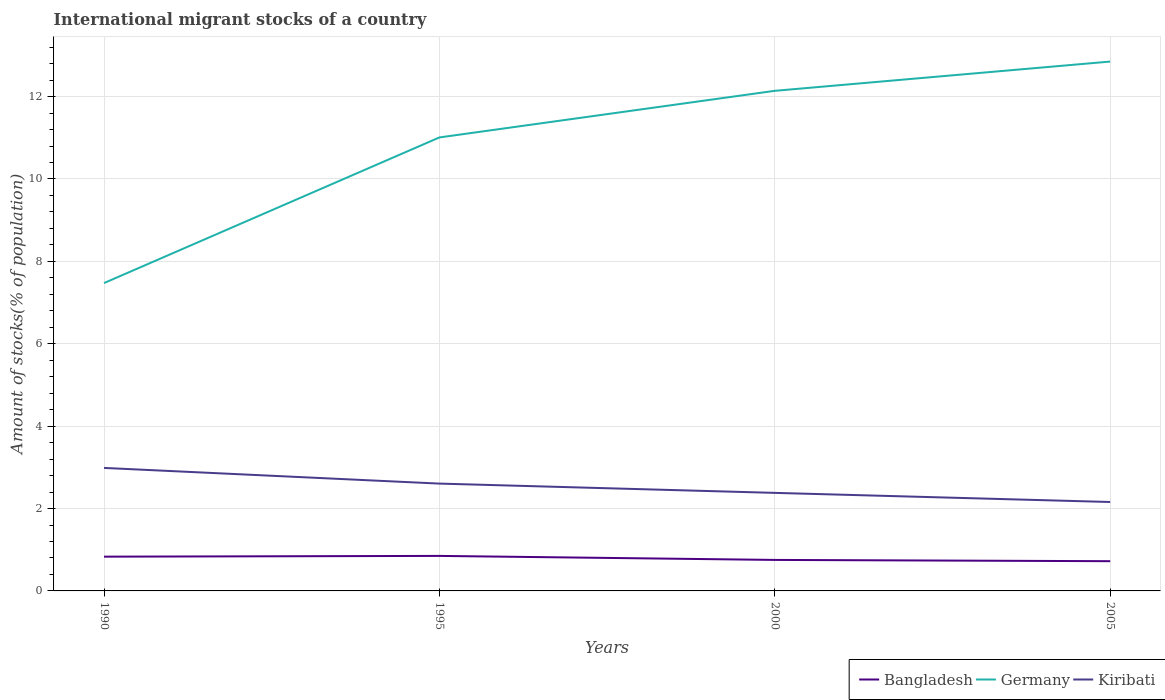Does the line corresponding to Kiribati intersect with the line corresponding to Germany?
Provide a short and direct response. No. Across all years, what is the maximum amount of stocks in in Kiribati?
Your answer should be very brief. 2.16. What is the total amount of stocks in in Kiribati in the graph?
Keep it short and to the point. 0.23. What is the difference between the highest and the second highest amount of stocks in in Germany?
Your answer should be compact. 5.38. What is the difference between two consecutive major ticks on the Y-axis?
Make the answer very short. 2. Are the values on the major ticks of Y-axis written in scientific E-notation?
Provide a short and direct response. No. Does the graph contain any zero values?
Your answer should be very brief. No. How many legend labels are there?
Offer a very short reply. 3. How are the legend labels stacked?
Provide a short and direct response. Horizontal. What is the title of the graph?
Your response must be concise. International migrant stocks of a country. What is the label or title of the Y-axis?
Make the answer very short. Amount of stocks(% of population). What is the Amount of stocks(% of population) in Bangladesh in 1990?
Offer a very short reply. 0.83. What is the Amount of stocks(% of population) of Germany in 1990?
Your answer should be compact. 7.47. What is the Amount of stocks(% of population) of Kiribati in 1990?
Your answer should be compact. 2.99. What is the Amount of stocks(% of population) of Bangladesh in 1995?
Your answer should be very brief. 0.85. What is the Amount of stocks(% of population) of Germany in 1995?
Provide a succinct answer. 11.01. What is the Amount of stocks(% of population) in Kiribati in 1995?
Offer a terse response. 2.61. What is the Amount of stocks(% of population) in Bangladesh in 2000?
Make the answer very short. 0.75. What is the Amount of stocks(% of population) in Germany in 2000?
Ensure brevity in your answer.  12.14. What is the Amount of stocks(% of population) in Kiribati in 2000?
Provide a succinct answer. 2.38. What is the Amount of stocks(% of population) in Bangladesh in 2005?
Offer a very short reply. 0.72. What is the Amount of stocks(% of population) in Germany in 2005?
Keep it short and to the point. 12.85. What is the Amount of stocks(% of population) in Kiribati in 2005?
Give a very brief answer. 2.16. Across all years, what is the maximum Amount of stocks(% of population) of Bangladesh?
Ensure brevity in your answer.  0.85. Across all years, what is the maximum Amount of stocks(% of population) in Germany?
Keep it short and to the point. 12.85. Across all years, what is the maximum Amount of stocks(% of population) in Kiribati?
Your answer should be compact. 2.99. Across all years, what is the minimum Amount of stocks(% of population) of Bangladesh?
Your answer should be very brief. 0.72. Across all years, what is the minimum Amount of stocks(% of population) in Germany?
Make the answer very short. 7.47. Across all years, what is the minimum Amount of stocks(% of population) of Kiribati?
Offer a very short reply. 2.16. What is the total Amount of stocks(% of population) of Bangladesh in the graph?
Your response must be concise. 3.16. What is the total Amount of stocks(% of population) in Germany in the graph?
Offer a terse response. 43.47. What is the total Amount of stocks(% of population) in Kiribati in the graph?
Provide a succinct answer. 10.13. What is the difference between the Amount of stocks(% of population) in Bangladesh in 1990 and that in 1995?
Make the answer very short. -0.02. What is the difference between the Amount of stocks(% of population) in Germany in 1990 and that in 1995?
Your answer should be compact. -3.54. What is the difference between the Amount of stocks(% of population) in Kiribati in 1990 and that in 1995?
Your answer should be very brief. 0.38. What is the difference between the Amount of stocks(% of population) of Bangladesh in 1990 and that in 2000?
Provide a succinct answer. 0.08. What is the difference between the Amount of stocks(% of population) of Germany in 1990 and that in 2000?
Your answer should be very brief. -4.67. What is the difference between the Amount of stocks(% of population) in Kiribati in 1990 and that in 2000?
Offer a very short reply. 0.61. What is the difference between the Amount of stocks(% of population) in Bangladesh in 1990 and that in 2005?
Your response must be concise. 0.11. What is the difference between the Amount of stocks(% of population) in Germany in 1990 and that in 2005?
Ensure brevity in your answer.  -5.38. What is the difference between the Amount of stocks(% of population) of Kiribati in 1990 and that in 2005?
Your answer should be compact. 0.83. What is the difference between the Amount of stocks(% of population) in Bangladesh in 1995 and that in 2000?
Provide a succinct answer. 0.1. What is the difference between the Amount of stocks(% of population) of Germany in 1995 and that in 2000?
Your response must be concise. -1.13. What is the difference between the Amount of stocks(% of population) of Kiribati in 1995 and that in 2000?
Offer a terse response. 0.23. What is the difference between the Amount of stocks(% of population) of Bangladesh in 1995 and that in 2005?
Offer a very short reply. 0.13. What is the difference between the Amount of stocks(% of population) in Germany in 1995 and that in 2005?
Offer a very short reply. -1.84. What is the difference between the Amount of stocks(% of population) in Kiribati in 1995 and that in 2005?
Offer a very short reply. 0.45. What is the difference between the Amount of stocks(% of population) of Bangladesh in 2000 and that in 2005?
Your answer should be very brief. 0.03. What is the difference between the Amount of stocks(% of population) in Germany in 2000 and that in 2005?
Your answer should be very brief. -0.71. What is the difference between the Amount of stocks(% of population) of Kiribati in 2000 and that in 2005?
Provide a short and direct response. 0.22. What is the difference between the Amount of stocks(% of population) in Bangladesh in 1990 and the Amount of stocks(% of population) in Germany in 1995?
Your answer should be very brief. -10.18. What is the difference between the Amount of stocks(% of population) in Bangladesh in 1990 and the Amount of stocks(% of population) in Kiribati in 1995?
Ensure brevity in your answer.  -1.77. What is the difference between the Amount of stocks(% of population) of Germany in 1990 and the Amount of stocks(% of population) of Kiribati in 1995?
Keep it short and to the point. 4.87. What is the difference between the Amount of stocks(% of population) in Bangladesh in 1990 and the Amount of stocks(% of population) in Germany in 2000?
Provide a succinct answer. -11.31. What is the difference between the Amount of stocks(% of population) in Bangladesh in 1990 and the Amount of stocks(% of population) in Kiribati in 2000?
Your response must be concise. -1.55. What is the difference between the Amount of stocks(% of population) of Germany in 1990 and the Amount of stocks(% of population) of Kiribati in 2000?
Keep it short and to the point. 5.09. What is the difference between the Amount of stocks(% of population) of Bangladesh in 1990 and the Amount of stocks(% of population) of Germany in 2005?
Your answer should be very brief. -12.02. What is the difference between the Amount of stocks(% of population) of Bangladesh in 1990 and the Amount of stocks(% of population) of Kiribati in 2005?
Offer a terse response. -1.33. What is the difference between the Amount of stocks(% of population) of Germany in 1990 and the Amount of stocks(% of population) of Kiribati in 2005?
Provide a succinct answer. 5.31. What is the difference between the Amount of stocks(% of population) of Bangladesh in 1995 and the Amount of stocks(% of population) of Germany in 2000?
Ensure brevity in your answer.  -11.29. What is the difference between the Amount of stocks(% of population) in Bangladesh in 1995 and the Amount of stocks(% of population) in Kiribati in 2000?
Make the answer very short. -1.53. What is the difference between the Amount of stocks(% of population) of Germany in 1995 and the Amount of stocks(% of population) of Kiribati in 2000?
Your answer should be very brief. 8.63. What is the difference between the Amount of stocks(% of population) in Bangladesh in 1995 and the Amount of stocks(% of population) in Germany in 2005?
Provide a succinct answer. -12. What is the difference between the Amount of stocks(% of population) in Bangladesh in 1995 and the Amount of stocks(% of population) in Kiribati in 2005?
Ensure brevity in your answer.  -1.31. What is the difference between the Amount of stocks(% of population) of Germany in 1995 and the Amount of stocks(% of population) of Kiribati in 2005?
Provide a succinct answer. 8.85. What is the difference between the Amount of stocks(% of population) of Bangladesh in 2000 and the Amount of stocks(% of population) of Germany in 2005?
Ensure brevity in your answer.  -12.1. What is the difference between the Amount of stocks(% of population) in Bangladesh in 2000 and the Amount of stocks(% of population) in Kiribati in 2005?
Provide a short and direct response. -1.41. What is the difference between the Amount of stocks(% of population) in Germany in 2000 and the Amount of stocks(% of population) in Kiribati in 2005?
Make the answer very short. 9.98. What is the average Amount of stocks(% of population) of Bangladesh per year?
Your answer should be very brief. 0.79. What is the average Amount of stocks(% of population) in Germany per year?
Give a very brief answer. 10.87. What is the average Amount of stocks(% of population) in Kiribati per year?
Your answer should be compact. 2.53. In the year 1990, what is the difference between the Amount of stocks(% of population) in Bangladesh and Amount of stocks(% of population) in Germany?
Offer a very short reply. -6.64. In the year 1990, what is the difference between the Amount of stocks(% of population) of Bangladesh and Amount of stocks(% of population) of Kiribati?
Provide a short and direct response. -2.15. In the year 1990, what is the difference between the Amount of stocks(% of population) of Germany and Amount of stocks(% of population) of Kiribati?
Ensure brevity in your answer.  4.49. In the year 1995, what is the difference between the Amount of stocks(% of population) in Bangladesh and Amount of stocks(% of population) in Germany?
Offer a terse response. -10.16. In the year 1995, what is the difference between the Amount of stocks(% of population) of Bangladesh and Amount of stocks(% of population) of Kiribati?
Provide a succinct answer. -1.76. In the year 1995, what is the difference between the Amount of stocks(% of population) of Germany and Amount of stocks(% of population) of Kiribati?
Give a very brief answer. 8.4. In the year 2000, what is the difference between the Amount of stocks(% of population) in Bangladesh and Amount of stocks(% of population) in Germany?
Offer a terse response. -11.39. In the year 2000, what is the difference between the Amount of stocks(% of population) of Bangladesh and Amount of stocks(% of population) of Kiribati?
Make the answer very short. -1.63. In the year 2000, what is the difference between the Amount of stocks(% of population) of Germany and Amount of stocks(% of population) of Kiribati?
Give a very brief answer. 9.76. In the year 2005, what is the difference between the Amount of stocks(% of population) in Bangladesh and Amount of stocks(% of population) in Germany?
Offer a very short reply. -12.13. In the year 2005, what is the difference between the Amount of stocks(% of population) of Bangladesh and Amount of stocks(% of population) of Kiribati?
Give a very brief answer. -1.44. In the year 2005, what is the difference between the Amount of stocks(% of population) in Germany and Amount of stocks(% of population) in Kiribati?
Offer a very short reply. 10.69. What is the ratio of the Amount of stocks(% of population) of Bangladesh in 1990 to that in 1995?
Offer a very short reply. 0.98. What is the ratio of the Amount of stocks(% of population) in Germany in 1990 to that in 1995?
Ensure brevity in your answer.  0.68. What is the ratio of the Amount of stocks(% of population) in Kiribati in 1990 to that in 1995?
Ensure brevity in your answer.  1.15. What is the ratio of the Amount of stocks(% of population) in Bangladesh in 1990 to that in 2000?
Keep it short and to the point. 1.11. What is the ratio of the Amount of stocks(% of population) in Germany in 1990 to that in 2000?
Make the answer very short. 0.62. What is the ratio of the Amount of stocks(% of population) of Kiribati in 1990 to that in 2000?
Make the answer very short. 1.25. What is the ratio of the Amount of stocks(% of population) of Bangladesh in 1990 to that in 2005?
Give a very brief answer. 1.15. What is the ratio of the Amount of stocks(% of population) in Germany in 1990 to that in 2005?
Your response must be concise. 0.58. What is the ratio of the Amount of stocks(% of population) in Kiribati in 1990 to that in 2005?
Offer a very short reply. 1.38. What is the ratio of the Amount of stocks(% of population) of Bangladesh in 1995 to that in 2000?
Give a very brief answer. 1.13. What is the ratio of the Amount of stocks(% of population) in Germany in 1995 to that in 2000?
Offer a terse response. 0.91. What is the ratio of the Amount of stocks(% of population) of Kiribati in 1995 to that in 2000?
Provide a succinct answer. 1.09. What is the ratio of the Amount of stocks(% of population) of Bangladesh in 1995 to that in 2005?
Provide a short and direct response. 1.18. What is the ratio of the Amount of stocks(% of population) in Germany in 1995 to that in 2005?
Your answer should be compact. 0.86. What is the ratio of the Amount of stocks(% of population) of Kiribati in 1995 to that in 2005?
Offer a very short reply. 1.21. What is the ratio of the Amount of stocks(% of population) of Bangladesh in 2000 to that in 2005?
Offer a terse response. 1.04. What is the ratio of the Amount of stocks(% of population) of Germany in 2000 to that in 2005?
Make the answer very short. 0.94. What is the ratio of the Amount of stocks(% of population) in Kiribati in 2000 to that in 2005?
Offer a very short reply. 1.1. What is the difference between the highest and the second highest Amount of stocks(% of population) of Bangladesh?
Give a very brief answer. 0.02. What is the difference between the highest and the second highest Amount of stocks(% of population) in Germany?
Your answer should be very brief. 0.71. What is the difference between the highest and the second highest Amount of stocks(% of population) in Kiribati?
Give a very brief answer. 0.38. What is the difference between the highest and the lowest Amount of stocks(% of population) of Bangladesh?
Offer a very short reply. 0.13. What is the difference between the highest and the lowest Amount of stocks(% of population) in Germany?
Your answer should be very brief. 5.38. What is the difference between the highest and the lowest Amount of stocks(% of population) of Kiribati?
Ensure brevity in your answer.  0.83. 